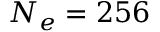Convert formula to latex. <formula><loc_0><loc_0><loc_500><loc_500>N _ { e } = 2 5 6</formula> 